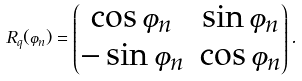<formula> <loc_0><loc_0><loc_500><loc_500>R _ { q } ( \varphi _ { n } ) = \begin{pmatrix} \cos \varphi _ { n } & \sin \varphi _ { n } \\ - \sin \varphi _ { n } & \cos \varphi _ { n } \\ \end{pmatrix} .</formula> 